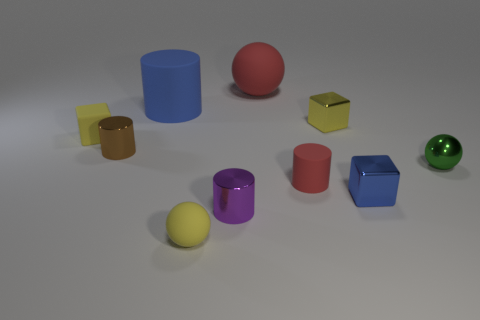Do the big ball and the tiny blue cube have the same material?
Give a very brief answer. No. What material is the small yellow block on the left side of the large matte thing on the right side of the small yellow matte sphere?
Offer a terse response. Rubber. Are there more small cubes that are on the right side of the yellow shiny cube than big blue rubber things?
Make the answer very short. No. What number of other things are the same size as the blue cylinder?
Ensure brevity in your answer.  1. Does the big ball have the same color as the small matte block?
Your answer should be very brief. No. What is the color of the matte cylinder behind the small cube to the left of the small metal cylinder to the left of the big blue matte cylinder?
Keep it short and to the point. Blue. What number of tiny green metallic spheres are behind the rubber ball in front of the matte thing that is behind the big blue cylinder?
Offer a very short reply. 1. Are there any other things that are the same color as the large ball?
Provide a short and direct response. Yes. There is a yellow thing that is in front of the green sphere; is its size the same as the brown cylinder?
Give a very brief answer. Yes. There is a tiny yellow object in front of the small brown metal cylinder; how many objects are on the left side of it?
Offer a very short reply. 3. 